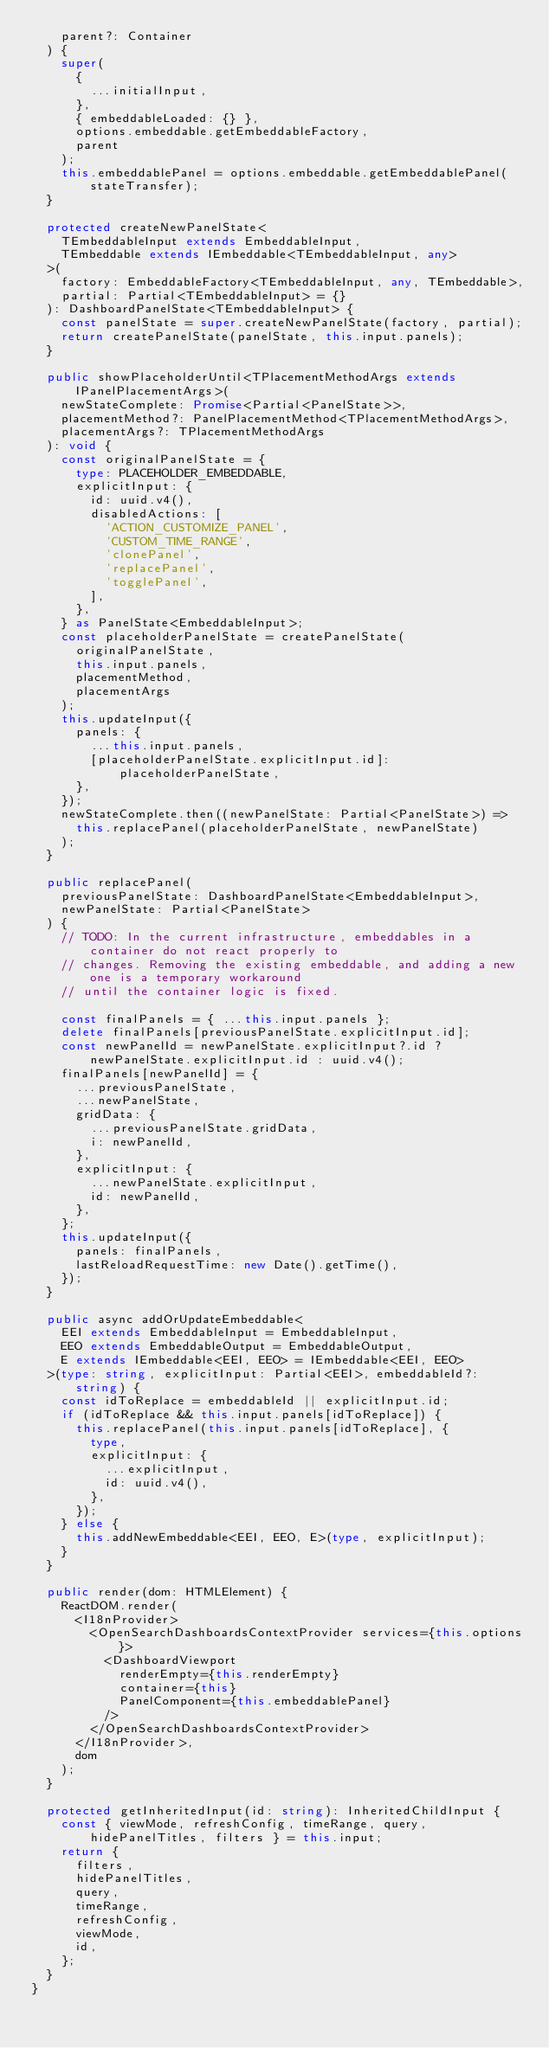Convert code to text. <code><loc_0><loc_0><loc_500><loc_500><_TypeScript_>    parent?: Container
  ) {
    super(
      {
        ...initialInput,
      },
      { embeddableLoaded: {} },
      options.embeddable.getEmbeddableFactory,
      parent
    );
    this.embeddablePanel = options.embeddable.getEmbeddablePanel(stateTransfer);
  }

  protected createNewPanelState<
    TEmbeddableInput extends EmbeddableInput,
    TEmbeddable extends IEmbeddable<TEmbeddableInput, any>
  >(
    factory: EmbeddableFactory<TEmbeddableInput, any, TEmbeddable>,
    partial: Partial<TEmbeddableInput> = {}
  ): DashboardPanelState<TEmbeddableInput> {
    const panelState = super.createNewPanelState(factory, partial);
    return createPanelState(panelState, this.input.panels);
  }

  public showPlaceholderUntil<TPlacementMethodArgs extends IPanelPlacementArgs>(
    newStateComplete: Promise<Partial<PanelState>>,
    placementMethod?: PanelPlacementMethod<TPlacementMethodArgs>,
    placementArgs?: TPlacementMethodArgs
  ): void {
    const originalPanelState = {
      type: PLACEHOLDER_EMBEDDABLE,
      explicitInput: {
        id: uuid.v4(),
        disabledActions: [
          'ACTION_CUSTOMIZE_PANEL',
          'CUSTOM_TIME_RANGE',
          'clonePanel',
          'replacePanel',
          'togglePanel',
        ],
      },
    } as PanelState<EmbeddableInput>;
    const placeholderPanelState = createPanelState(
      originalPanelState,
      this.input.panels,
      placementMethod,
      placementArgs
    );
    this.updateInput({
      panels: {
        ...this.input.panels,
        [placeholderPanelState.explicitInput.id]: placeholderPanelState,
      },
    });
    newStateComplete.then((newPanelState: Partial<PanelState>) =>
      this.replacePanel(placeholderPanelState, newPanelState)
    );
  }

  public replacePanel(
    previousPanelState: DashboardPanelState<EmbeddableInput>,
    newPanelState: Partial<PanelState>
  ) {
    // TODO: In the current infrastructure, embeddables in a container do not react properly to
    // changes. Removing the existing embeddable, and adding a new one is a temporary workaround
    // until the container logic is fixed.

    const finalPanels = { ...this.input.panels };
    delete finalPanels[previousPanelState.explicitInput.id];
    const newPanelId = newPanelState.explicitInput?.id ? newPanelState.explicitInput.id : uuid.v4();
    finalPanels[newPanelId] = {
      ...previousPanelState,
      ...newPanelState,
      gridData: {
        ...previousPanelState.gridData,
        i: newPanelId,
      },
      explicitInput: {
        ...newPanelState.explicitInput,
        id: newPanelId,
      },
    };
    this.updateInput({
      panels: finalPanels,
      lastReloadRequestTime: new Date().getTime(),
    });
  }

  public async addOrUpdateEmbeddable<
    EEI extends EmbeddableInput = EmbeddableInput,
    EEO extends EmbeddableOutput = EmbeddableOutput,
    E extends IEmbeddable<EEI, EEO> = IEmbeddable<EEI, EEO>
  >(type: string, explicitInput: Partial<EEI>, embeddableId?: string) {
    const idToReplace = embeddableId || explicitInput.id;
    if (idToReplace && this.input.panels[idToReplace]) {
      this.replacePanel(this.input.panels[idToReplace], {
        type,
        explicitInput: {
          ...explicitInput,
          id: uuid.v4(),
        },
      });
    } else {
      this.addNewEmbeddable<EEI, EEO, E>(type, explicitInput);
    }
  }

  public render(dom: HTMLElement) {
    ReactDOM.render(
      <I18nProvider>
        <OpenSearchDashboardsContextProvider services={this.options}>
          <DashboardViewport
            renderEmpty={this.renderEmpty}
            container={this}
            PanelComponent={this.embeddablePanel}
          />
        </OpenSearchDashboardsContextProvider>
      </I18nProvider>,
      dom
    );
  }

  protected getInheritedInput(id: string): InheritedChildInput {
    const { viewMode, refreshConfig, timeRange, query, hidePanelTitles, filters } = this.input;
    return {
      filters,
      hidePanelTitles,
      query,
      timeRange,
      refreshConfig,
      viewMode,
      id,
    };
  }
}
</code> 